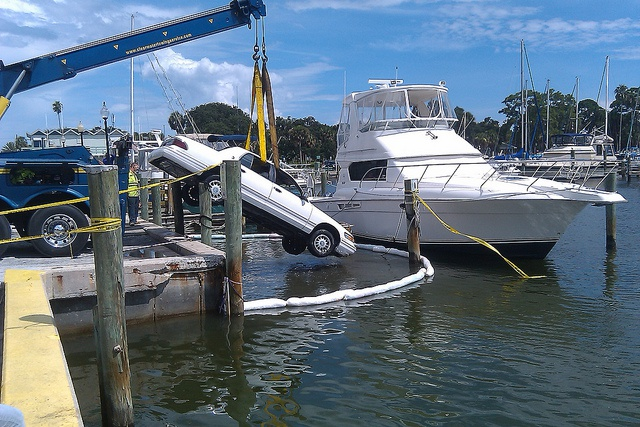Describe the objects in this image and their specific colors. I can see boat in white, gray, darkgray, and black tones, truck in white, black, navy, darkblue, and gray tones, car in white, black, gray, and darkgray tones, boat in white, darkgray, lightgray, black, and gray tones, and people in white, black, navy, gray, and khaki tones in this image. 